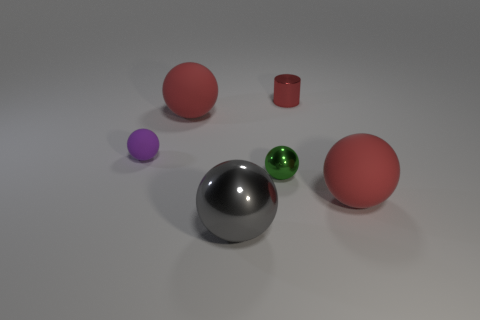The big red sphere that is right of the shiny object that is behind the large red sphere on the left side of the tiny red cylinder is made of what material?
Your answer should be very brief. Rubber. Do the small thing to the left of the large gray thing and the green object have the same shape?
Your response must be concise. Yes. There is a sphere that is on the right side of the red metallic cylinder; what is it made of?
Your answer should be compact. Rubber. How many metal things are either green objects or blue things?
Your answer should be compact. 1. Is there a gray metallic ball that has the same size as the gray metallic thing?
Offer a very short reply. No. Is the number of tiny green spheres on the left side of the purple object greater than the number of small matte things?
Keep it short and to the point. No. How many large objects are green rubber spheres or gray spheres?
Your answer should be very brief. 1. What number of big gray objects have the same shape as the small purple thing?
Keep it short and to the point. 1. What is the material of the small green object in front of the large red matte thing behind the purple object?
Make the answer very short. Metal. There is a red rubber object that is left of the red cylinder; what size is it?
Provide a short and direct response. Large. 